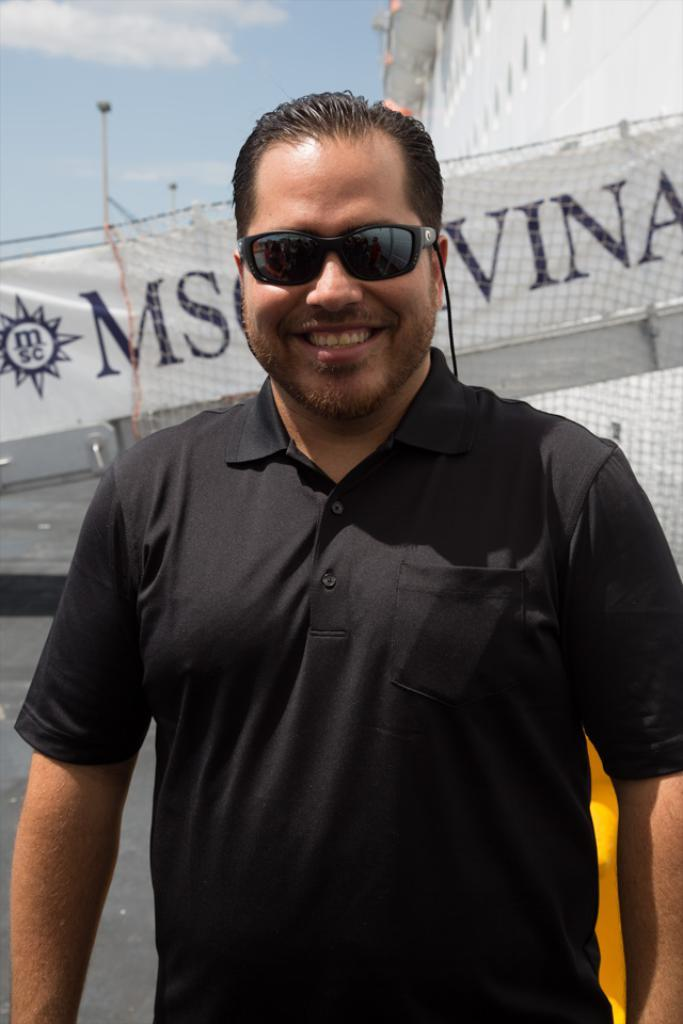What is the main subject of the image? The main subject of the image is a man. What is the man wearing in the image? The man is wearing a black T-shirt. Are there any accessories visible on the man in the image? Yes, the man is wearing spectacles. What is the man's facial expression in the image? The man is smiling in the image. What can be seen in the background of the image? Sky is visible in the background of the image. Is the man sinking in quicksand in the image? No, there is no quicksand present in the image. What type of collar is the man wearing in the image? The man is not wearing a collar in the image, as he is wearing a T-shirt. 